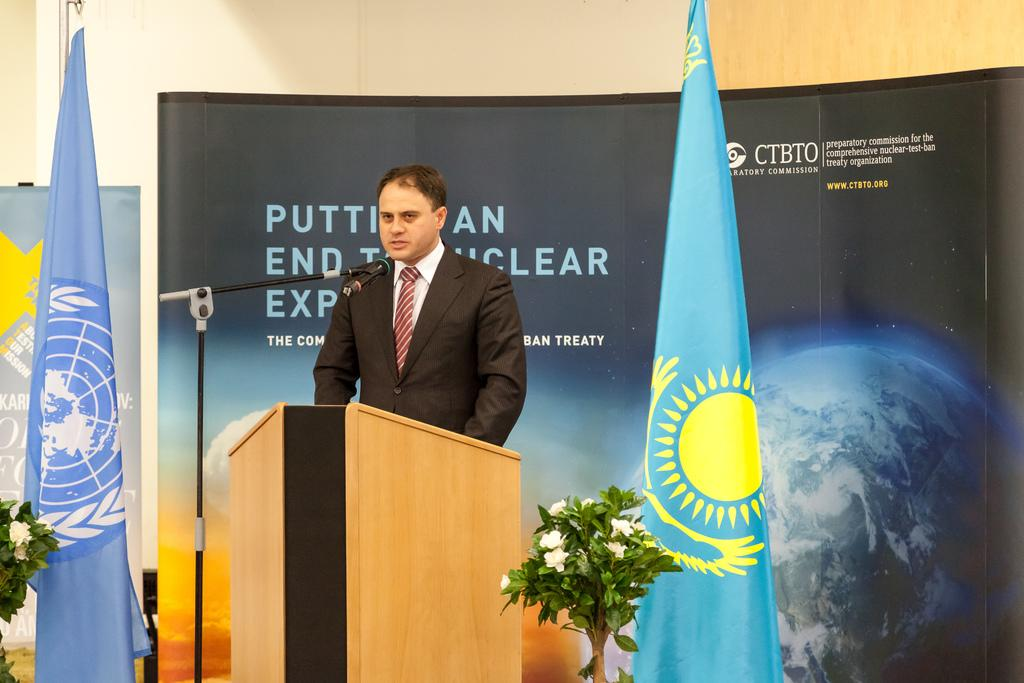What is the person in the image doing? The person is standing in front of a podium and speaking into a microphone. What can be seen beside the person? There are plants beside the person. What is in front of the wall in the image? There are flags and banners in front of the wall. What type of cheese is being served on the vacation in the image? There is no vacation or cheese present in the image; it features a person speaking at a podium with plants, flags, and banners nearby. 